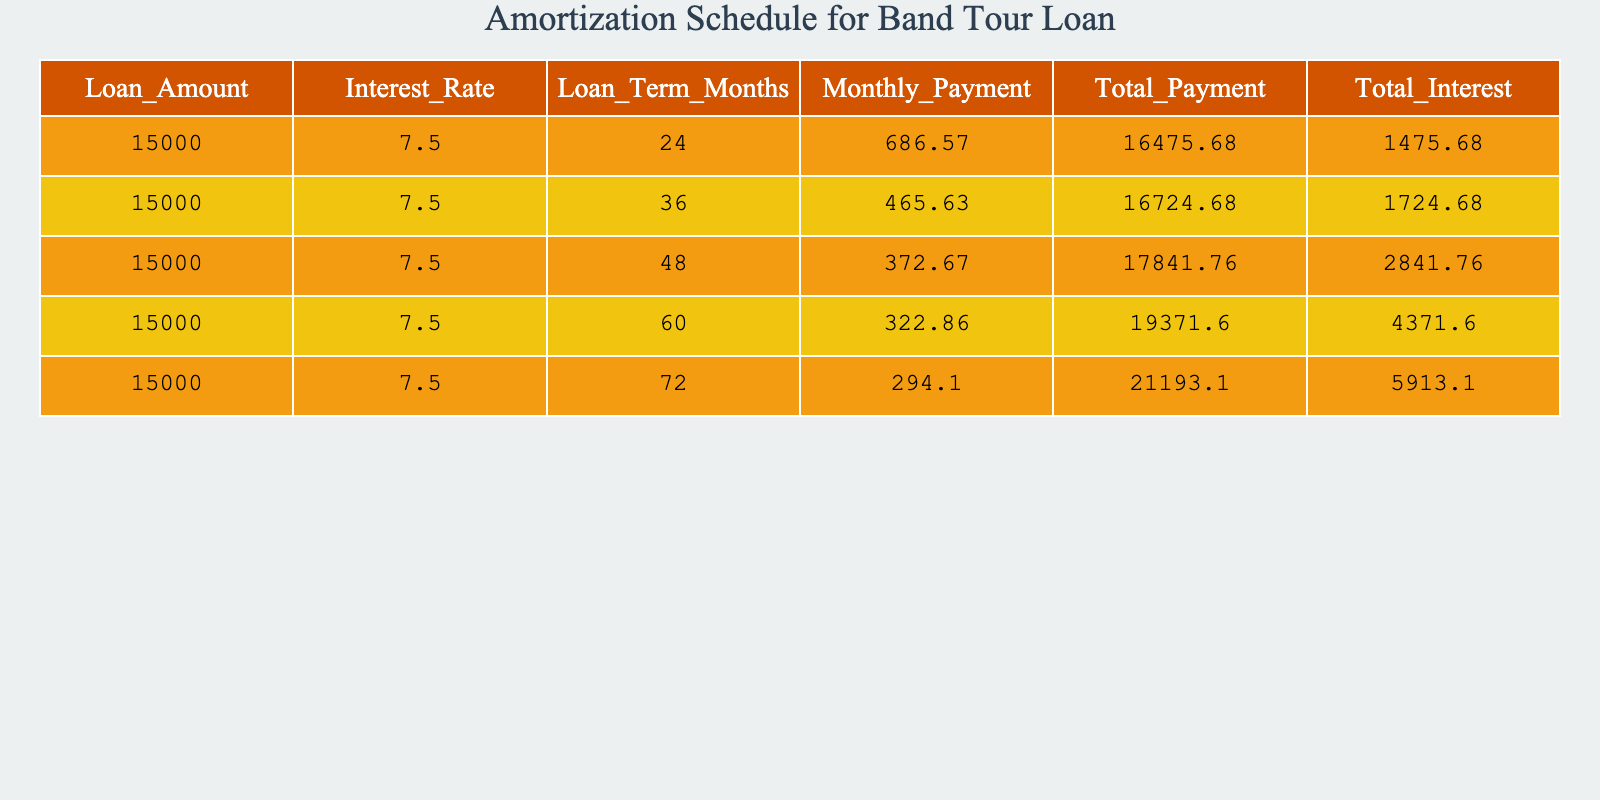What is the monthly payment for a loan term of 60 months? The table indicates that the monthly payment for a loan term of 60 months is $322.86.
Answer: 322.86 What is the total payment for the loan over 48 months? According to the table, the total payment for the loan over 48 months is $17,841.76.
Answer: 17841.76 Is the total interest paid higher for a 72-month loan than for a 36-month loan? The total interest paid for the 72-month loan is $5,913.10, while for the 36-month loan it is $1,724.68, which means the interest for the 72-month loan is indeed higher.
Answer: Yes What is the total interest paid for the loan over all terms combined? By adding all the total interest payments from the table: 1,475.68 + 1,724.68 + 2,841.76 + 4,371.60 + 5,913.10 = 16,526.80, so that is the total.
Answer: 16526.80 How much more is the total payment for the 72-month loan compared to the 24-month loan? The total payment for the 72-month loan is $21,193.10 and for the 24-month loan is $16,475.68. The difference is 21,193.10 - 16,475.68 = 4,717.42.
Answer: 4717.42 